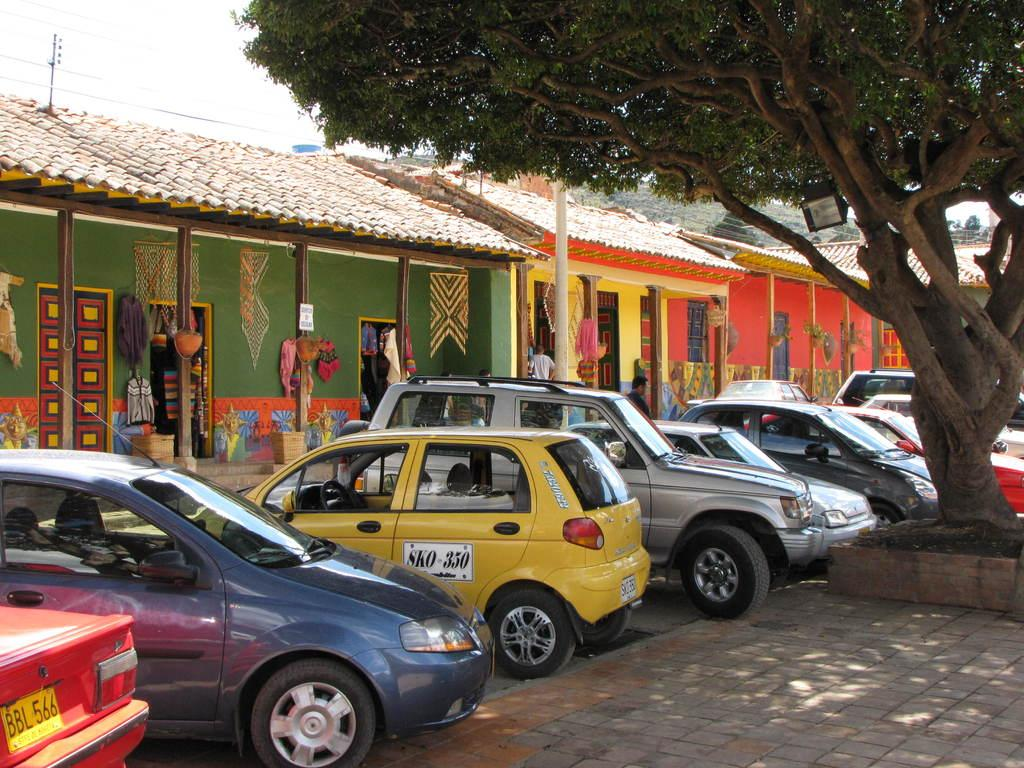Provide a one-sentence caption for the provided image. some cars with one that says sko on it. 